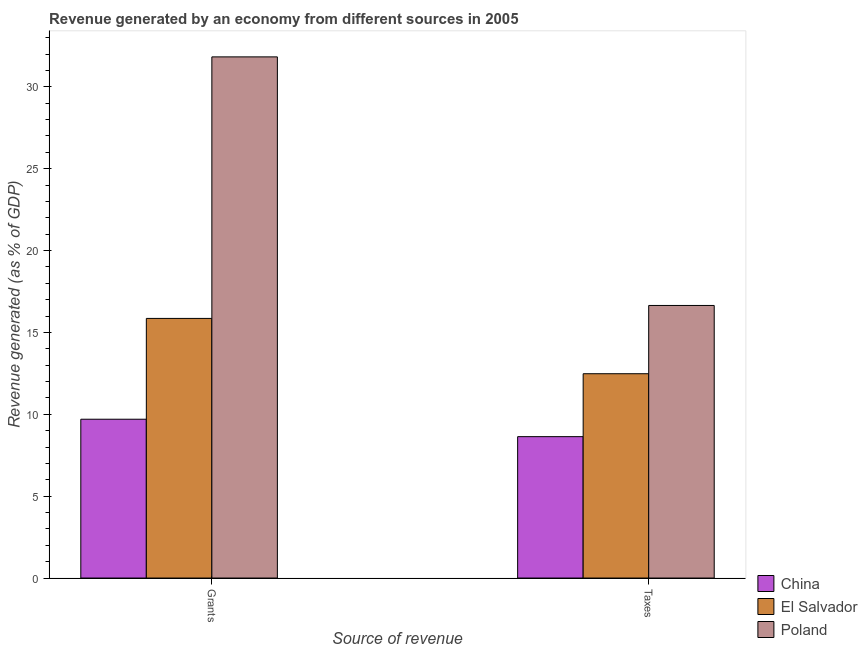How many different coloured bars are there?
Provide a short and direct response. 3. How many groups of bars are there?
Provide a short and direct response. 2. Are the number of bars per tick equal to the number of legend labels?
Ensure brevity in your answer.  Yes. Are the number of bars on each tick of the X-axis equal?
Your response must be concise. Yes. How many bars are there on the 1st tick from the left?
Keep it short and to the point. 3. What is the label of the 1st group of bars from the left?
Offer a terse response. Grants. What is the revenue generated by taxes in China?
Provide a short and direct response. 8.63. Across all countries, what is the maximum revenue generated by taxes?
Your response must be concise. 16.65. Across all countries, what is the minimum revenue generated by taxes?
Your answer should be very brief. 8.63. What is the total revenue generated by grants in the graph?
Make the answer very short. 57.38. What is the difference between the revenue generated by grants in China and that in El Salvador?
Your response must be concise. -6.16. What is the difference between the revenue generated by taxes in Poland and the revenue generated by grants in El Salvador?
Your answer should be very brief. 0.79. What is the average revenue generated by taxes per country?
Offer a very short reply. 12.59. What is the difference between the revenue generated by grants and revenue generated by taxes in El Salvador?
Offer a terse response. 3.38. What is the ratio of the revenue generated by grants in China to that in El Salvador?
Give a very brief answer. 0.61. Is the revenue generated by taxes in Poland less than that in El Salvador?
Provide a succinct answer. No. In how many countries, is the revenue generated by grants greater than the average revenue generated by grants taken over all countries?
Offer a terse response. 1. How many bars are there?
Offer a terse response. 6. What is the difference between two consecutive major ticks on the Y-axis?
Keep it short and to the point. 5. Where does the legend appear in the graph?
Give a very brief answer. Bottom right. How many legend labels are there?
Your answer should be very brief. 3. How are the legend labels stacked?
Keep it short and to the point. Vertical. What is the title of the graph?
Your answer should be very brief. Revenue generated by an economy from different sources in 2005. What is the label or title of the X-axis?
Give a very brief answer. Source of revenue. What is the label or title of the Y-axis?
Your response must be concise. Revenue generated (as % of GDP). What is the Revenue generated (as % of GDP) of China in Grants?
Keep it short and to the point. 9.7. What is the Revenue generated (as % of GDP) in El Salvador in Grants?
Ensure brevity in your answer.  15.86. What is the Revenue generated (as % of GDP) of Poland in Grants?
Offer a very short reply. 31.83. What is the Revenue generated (as % of GDP) of China in Taxes?
Your answer should be very brief. 8.63. What is the Revenue generated (as % of GDP) in El Salvador in Taxes?
Offer a terse response. 12.48. What is the Revenue generated (as % of GDP) of Poland in Taxes?
Your response must be concise. 16.65. Across all Source of revenue, what is the maximum Revenue generated (as % of GDP) in China?
Your answer should be very brief. 9.7. Across all Source of revenue, what is the maximum Revenue generated (as % of GDP) in El Salvador?
Provide a succinct answer. 15.86. Across all Source of revenue, what is the maximum Revenue generated (as % of GDP) of Poland?
Ensure brevity in your answer.  31.83. Across all Source of revenue, what is the minimum Revenue generated (as % of GDP) in China?
Provide a succinct answer. 8.63. Across all Source of revenue, what is the minimum Revenue generated (as % of GDP) in El Salvador?
Keep it short and to the point. 12.48. Across all Source of revenue, what is the minimum Revenue generated (as % of GDP) in Poland?
Provide a short and direct response. 16.65. What is the total Revenue generated (as % of GDP) in China in the graph?
Ensure brevity in your answer.  18.33. What is the total Revenue generated (as % of GDP) of El Salvador in the graph?
Keep it short and to the point. 28.33. What is the total Revenue generated (as % of GDP) of Poland in the graph?
Your response must be concise. 48.47. What is the difference between the Revenue generated (as % of GDP) of China in Grants and that in Taxes?
Offer a very short reply. 1.06. What is the difference between the Revenue generated (as % of GDP) in El Salvador in Grants and that in Taxes?
Give a very brief answer. 3.38. What is the difference between the Revenue generated (as % of GDP) of Poland in Grants and that in Taxes?
Your answer should be compact. 15.18. What is the difference between the Revenue generated (as % of GDP) of China in Grants and the Revenue generated (as % of GDP) of El Salvador in Taxes?
Provide a succinct answer. -2.78. What is the difference between the Revenue generated (as % of GDP) in China in Grants and the Revenue generated (as % of GDP) in Poland in Taxes?
Provide a short and direct response. -6.95. What is the difference between the Revenue generated (as % of GDP) of El Salvador in Grants and the Revenue generated (as % of GDP) of Poland in Taxes?
Offer a very short reply. -0.79. What is the average Revenue generated (as % of GDP) of China per Source of revenue?
Your answer should be very brief. 9.17. What is the average Revenue generated (as % of GDP) of El Salvador per Source of revenue?
Keep it short and to the point. 14.17. What is the average Revenue generated (as % of GDP) of Poland per Source of revenue?
Offer a very short reply. 24.24. What is the difference between the Revenue generated (as % of GDP) of China and Revenue generated (as % of GDP) of El Salvador in Grants?
Keep it short and to the point. -6.16. What is the difference between the Revenue generated (as % of GDP) in China and Revenue generated (as % of GDP) in Poland in Grants?
Make the answer very short. -22.13. What is the difference between the Revenue generated (as % of GDP) in El Salvador and Revenue generated (as % of GDP) in Poland in Grants?
Offer a terse response. -15.97. What is the difference between the Revenue generated (as % of GDP) in China and Revenue generated (as % of GDP) in El Salvador in Taxes?
Ensure brevity in your answer.  -3.84. What is the difference between the Revenue generated (as % of GDP) of China and Revenue generated (as % of GDP) of Poland in Taxes?
Ensure brevity in your answer.  -8.01. What is the difference between the Revenue generated (as % of GDP) of El Salvador and Revenue generated (as % of GDP) of Poland in Taxes?
Your answer should be very brief. -4.17. What is the ratio of the Revenue generated (as % of GDP) of China in Grants to that in Taxes?
Ensure brevity in your answer.  1.12. What is the ratio of the Revenue generated (as % of GDP) of El Salvador in Grants to that in Taxes?
Make the answer very short. 1.27. What is the ratio of the Revenue generated (as % of GDP) of Poland in Grants to that in Taxes?
Offer a terse response. 1.91. What is the difference between the highest and the second highest Revenue generated (as % of GDP) of China?
Give a very brief answer. 1.06. What is the difference between the highest and the second highest Revenue generated (as % of GDP) in El Salvador?
Your answer should be compact. 3.38. What is the difference between the highest and the second highest Revenue generated (as % of GDP) of Poland?
Give a very brief answer. 15.18. What is the difference between the highest and the lowest Revenue generated (as % of GDP) of China?
Your answer should be compact. 1.06. What is the difference between the highest and the lowest Revenue generated (as % of GDP) in El Salvador?
Provide a short and direct response. 3.38. What is the difference between the highest and the lowest Revenue generated (as % of GDP) of Poland?
Provide a short and direct response. 15.18. 